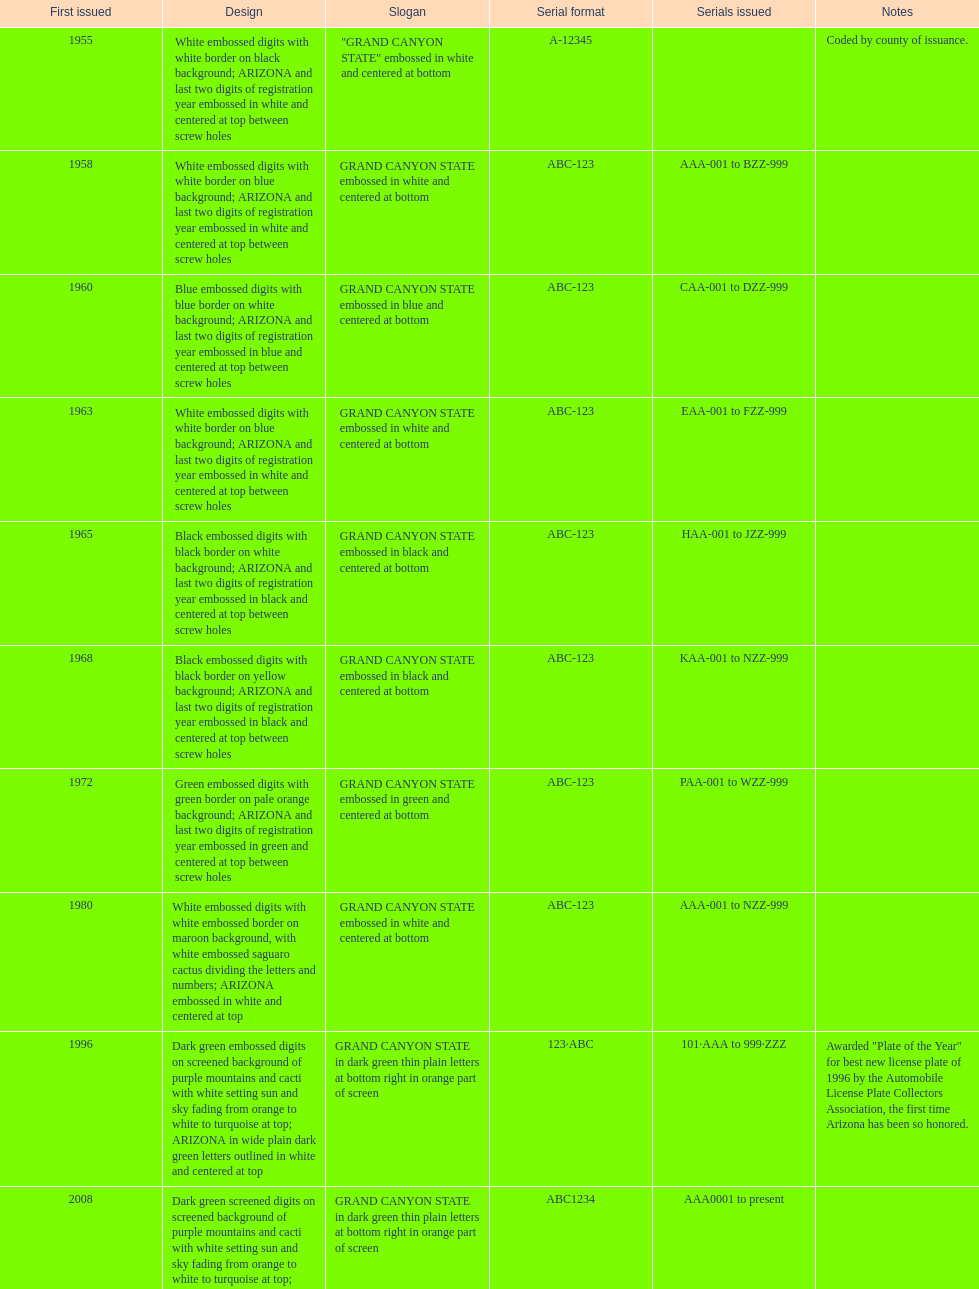In which year did the license plate have the fewest characters? 1955. 